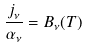<formula> <loc_0><loc_0><loc_500><loc_500>\frac { j _ { \nu } } { \alpha _ { \nu } } = B _ { \nu } ( T )</formula> 